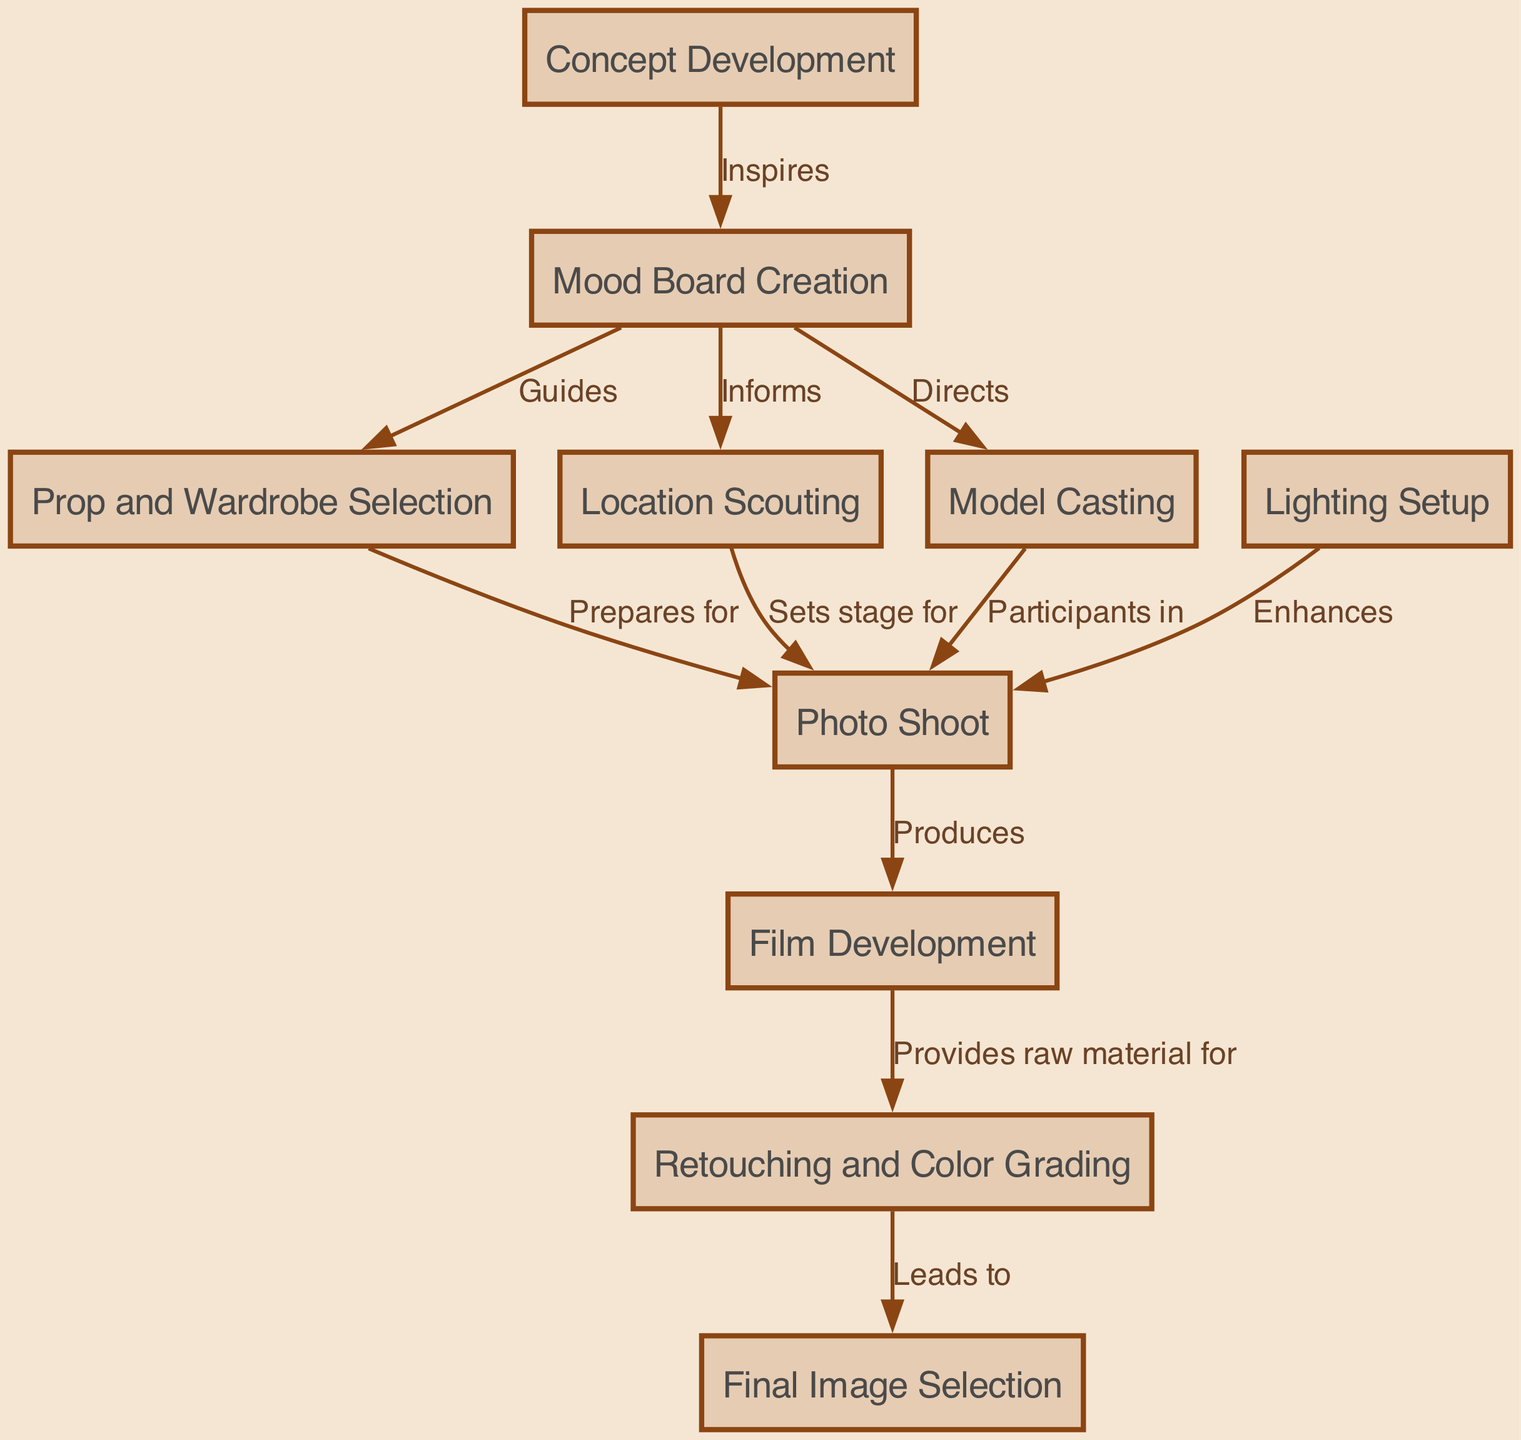What is the first step in the process? The first step is identified in the diagram as "Concept Development," which is the starting point before any other actions take place.
Answer: Concept Development How many nodes are present in the flowchart? By counting each individual item within the nodes section of the diagram, we find there are 10 nodes listed, each representing a distinct step in the photo shoot process.
Answer: 10 What step enhances the photo shoot? Looking at the flows in the diagram, the node labeled "Lighting Setup" is indicated to have a direct influence on the "Photo Shoot" step, which is described as enhancing it.
Answer: Lighting Setup Which node leads to the final image selection? By following the arrows in the diagram, the node "Retouching and Color Grading" is connected directly to "Final Image Selection," indicating that this process leads to the final selection.
Answer: Retouching and Color Grading What other node informs location scouting? The "Mood Board Creation" node not only guides prop and wardrobe selection but also informs location scouting, as indicated by the connections in the diagram.
Answer: Mood Board Creation What is the relationship between prop selection and the photo shoot? The diagram shows that "Prop and Wardrobe Selection" prepares for the "Photo Shoot," meaning it sets everything up for the actual photography.
Answer: Prepares for Which step provides raw material for retouching? The "Film Development" node is connected to "Retouching and Color Grading," which indicates that it supplies the raw images that will be edited.
Answer: Film Development How does model casting relate to the photo shoot? According to the diagram, "Model Casting" has a direct connection to the "Photo Shoot," denoting that models are participants in this process.
Answer: Participants in What three steps are involved before the photo shoot occurs? Reviewing the flowchart, the steps "Mood Board Creation," "Prop and Wardrobe Selection," and "Location Scouting" all occur prior to the "Photo Shoot", thus forming a preparatory sequence.
Answer: Mood Board Creation, Prop and Wardrobe Selection, Location Scouting 